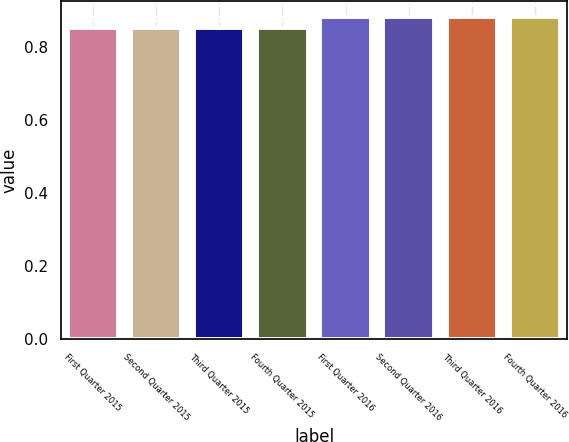<chart> <loc_0><loc_0><loc_500><loc_500><bar_chart><fcel>First Quarter 2015<fcel>Second Quarter 2015<fcel>Third Quarter 2015<fcel>Fourth Quarter 2015<fcel>First Quarter 2016<fcel>Second Quarter 2016<fcel>Third Quarter 2016<fcel>Fourth Quarter 2016<nl><fcel>0.85<fcel>0.85<fcel>0.85<fcel>0.85<fcel>0.88<fcel>0.88<fcel>0.88<fcel>0.88<nl></chart> 